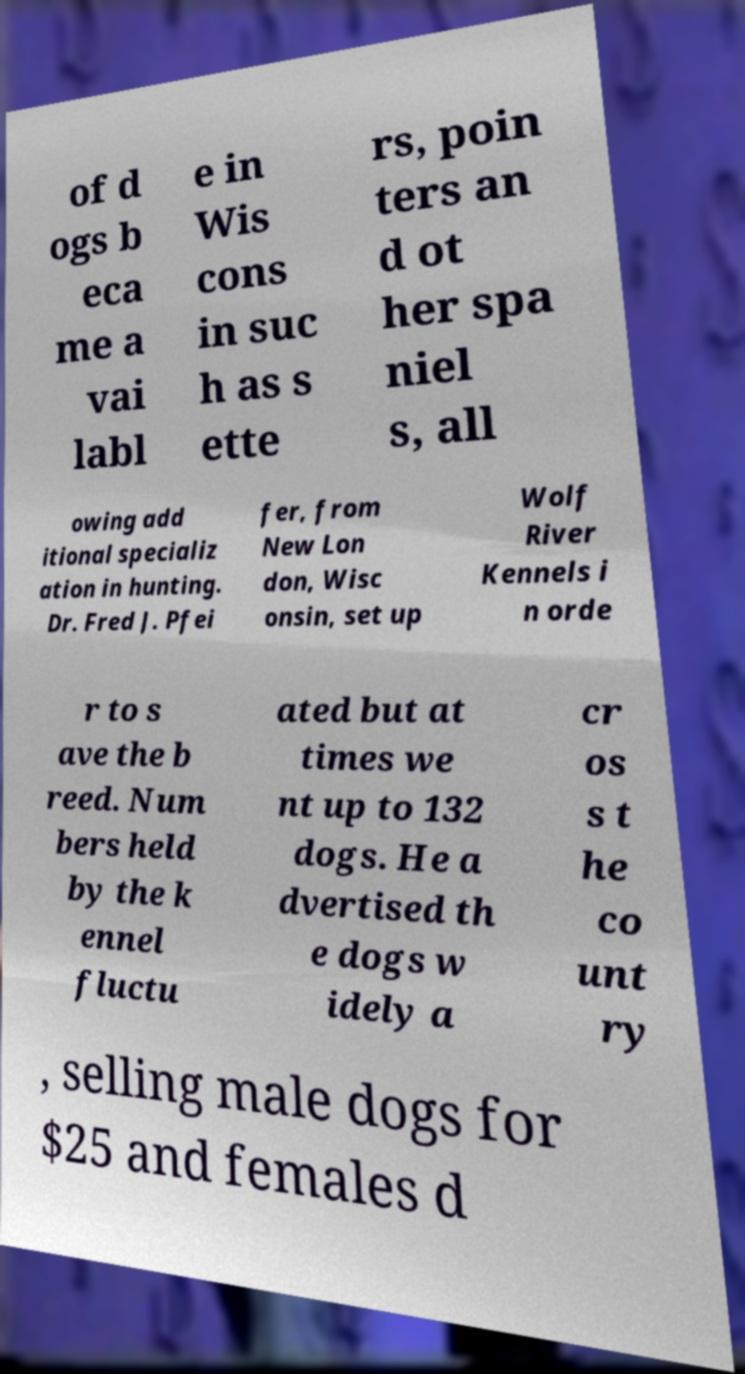For documentation purposes, I need the text within this image transcribed. Could you provide that? of d ogs b eca me a vai labl e in Wis cons in suc h as s ette rs, poin ters an d ot her spa niel s, all owing add itional specializ ation in hunting. Dr. Fred J. Pfei fer, from New Lon don, Wisc onsin, set up Wolf River Kennels i n orde r to s ave the b reed. Num bers held by the k ennel fluctu ated but at times we nt up to 132 dogs. He a dvertised th e dogs w idely a cr os s t he co unt ry , selling male dogs for $25 and females d 